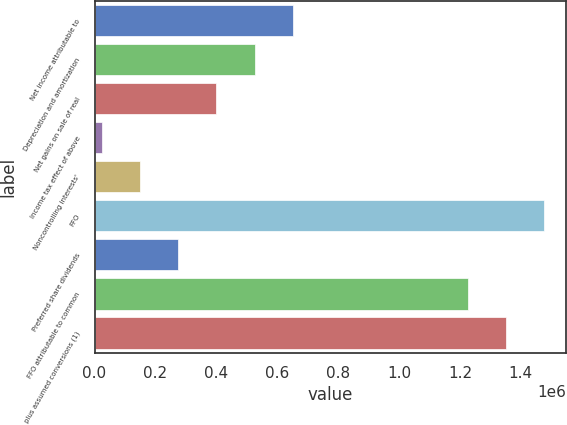<chart> <loc_0><loc_0><loc_500><loc_500><bar_chart><fcel>Net income attributable to<fcel>Depreciation and amortization<fcel>Net gains on sale of real<fcel>Income tax effect of above<fcel>Noncontrolling interests'<fcel>FFO<fcel>Preferred share dividends<fcel>FFO attributable to common<fcel>plus assumed conversions (1)<nl><fcel>650584<fcel>525380<fcel>400175<fcel>24561<fcel>149766<fcel>1.47587e+06<fcel>274970<fcel>1.22546e+06<fcel>1.35066e+06<nl></chart> 